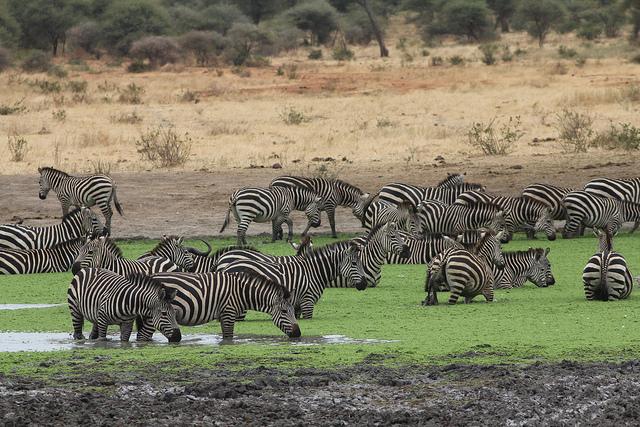What type of animal is this?
Give a very brief answer. Zebra. Is the land sparsely furnished?
Quick response, please. Yes. What are the zebras doing?
Answer briefly. Drinking water. 